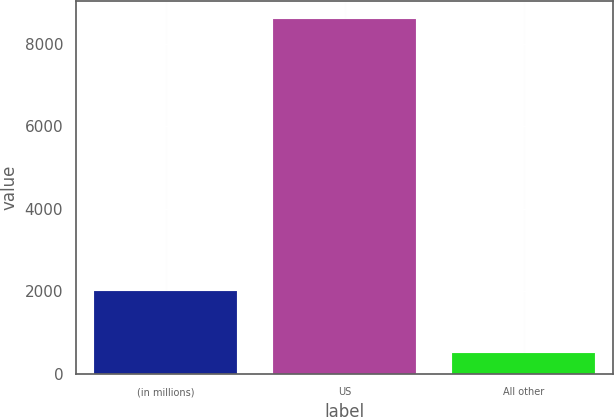Convert chart to OTSL. <chart><loc_0><loc_0><loc_500><loc_500><bar_chart><fcel>(in millions)<fcel>US<fcel>All other<nl><fcel>2015<fcel>8612<fcel>507<nl></chart> 